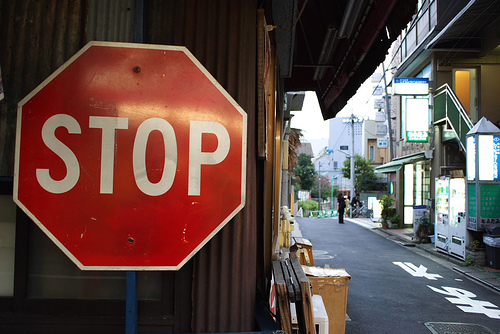Please transcribe the text information in this image. STOP 